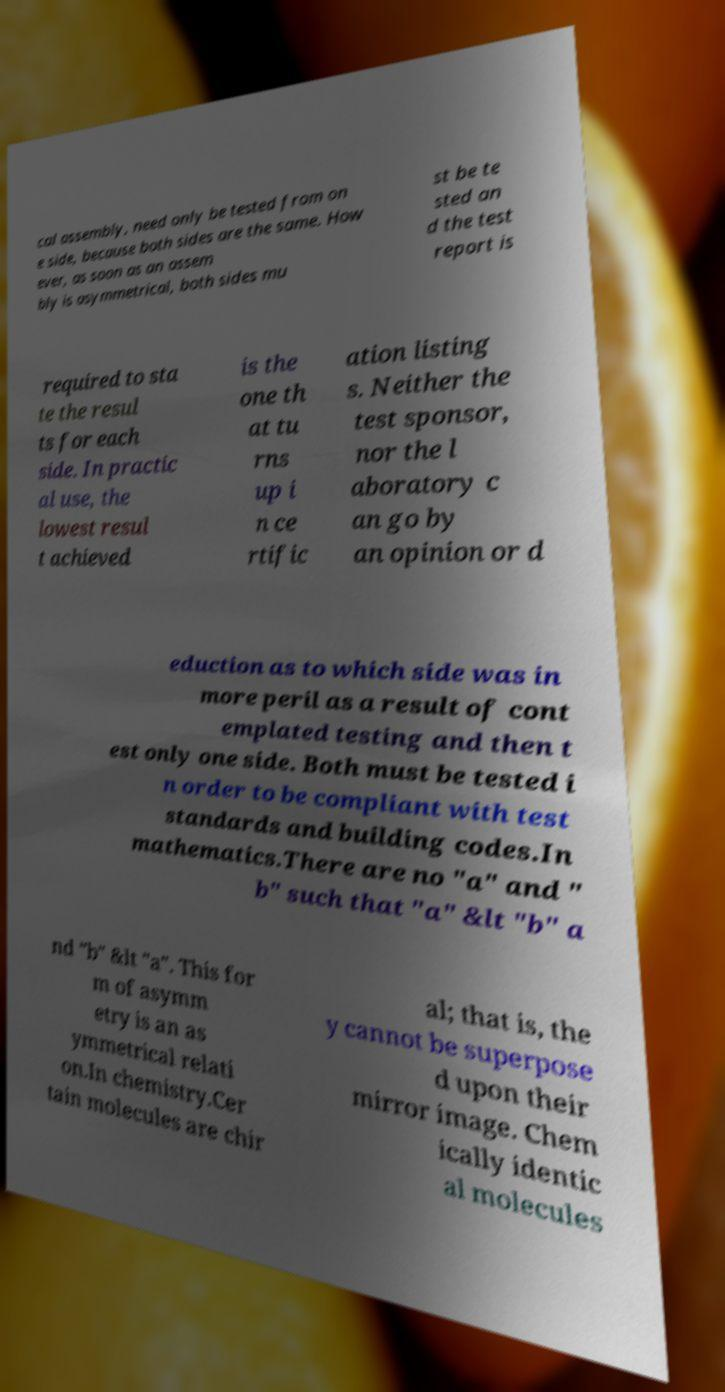There's text embedded in this image that I need extracted. Can you transcribe it verbatim? cal assembly, need only be tested from on e side, because both sides are the same. How ever, as soon as an assem bly is asymmetrical, both sides mu st be te sted an d the test report is required to sta te the resul ts for each side. In practic al use, the lowest resul t achieved is the one th at tu rns up i n ce rtific ation listing s. Neither the test sponsor, nor the l aboratory c an go by an opinion or d eduction as to which side was in more peril as a result of cont emplated testing and then t est only one side. Both must be tested i n order to be compliant with test standards and building codes.In mathematics.There are no "a" and " b" such that "a" &lt "b" a nd "b" &lt "a". This for m of asymm etry is an as ymmetrical relati on.In chemistry.Cer tain molecules are chir al; that is, the y cannot be superpose d upon their mirror image. Chem ically identic al molecules 